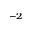Convert formula to latex. <formula><loc_0><loc_0><loc_500><loc_500>^ { - 2 }</formula> 